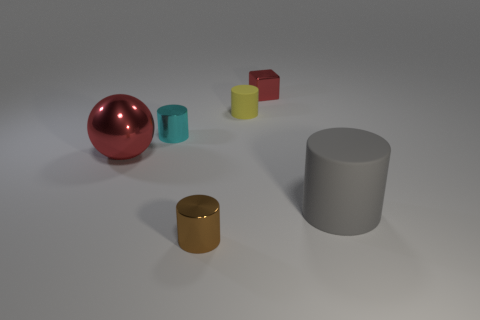Do the large object that is behind the big cylinder and the metallic cube have the same color?
Offer a terse response. Yes. There is a metal object that is the same color as the large metallic ball; what is its shape?
Your response must be concise. Cube. What number of small yellow cylinders are made of the same material as the tiny yellow object?
Your response must be concise. 0. There is a large gray matte thing; what number of brown cylinders are behind it?
Your response must be concise. 0. How big is the ball?
Make the answer very short. Large. The matte thing that is the same size as the block is what color?
Provide a succinct answer. Yellow. Are there any blocks that have the same color as the large matte cylinder?
Offer a very short reply. No. What material is the gray thing?
Your answer should be compact. Rubber. How many yellow rubber cubes are there?
Your answer should be very brief. 0. There is a big thing that is on the left side of the small red metal block; does it have the same color as the small metallic thing that is to the right of the yellow rubber object?
Your answer should be very brief. Yes. 